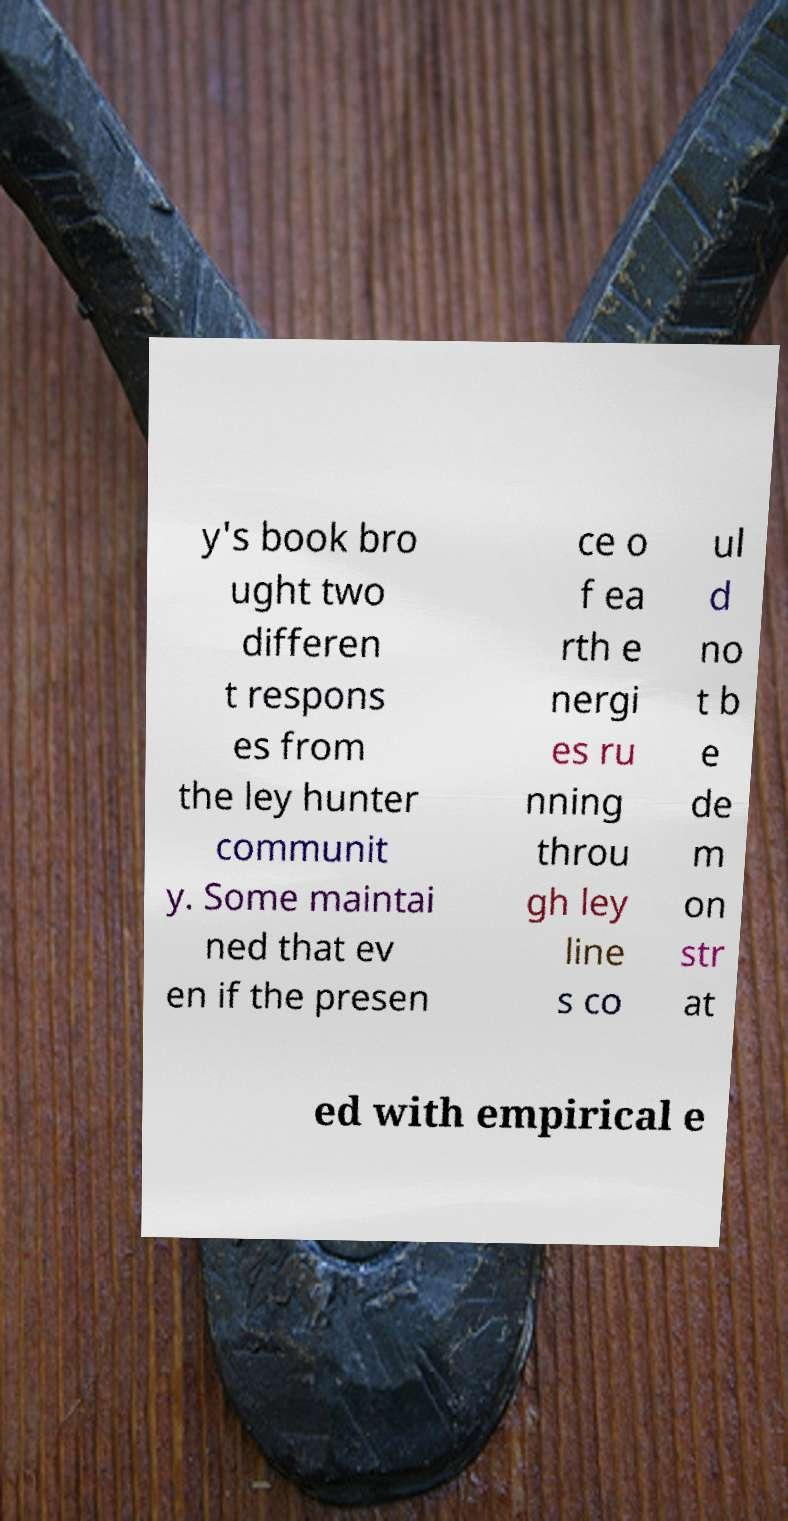Can you accurately transcribe the text from the provided image for me? y's book bro ught two differen t respons es from the ley hunter communit y. Some maintai ned that ev en if the presen ce o f ea rth e nergi es ru nning throu gh ley line s co ul d no t b e de m on str at ed with empirical e 